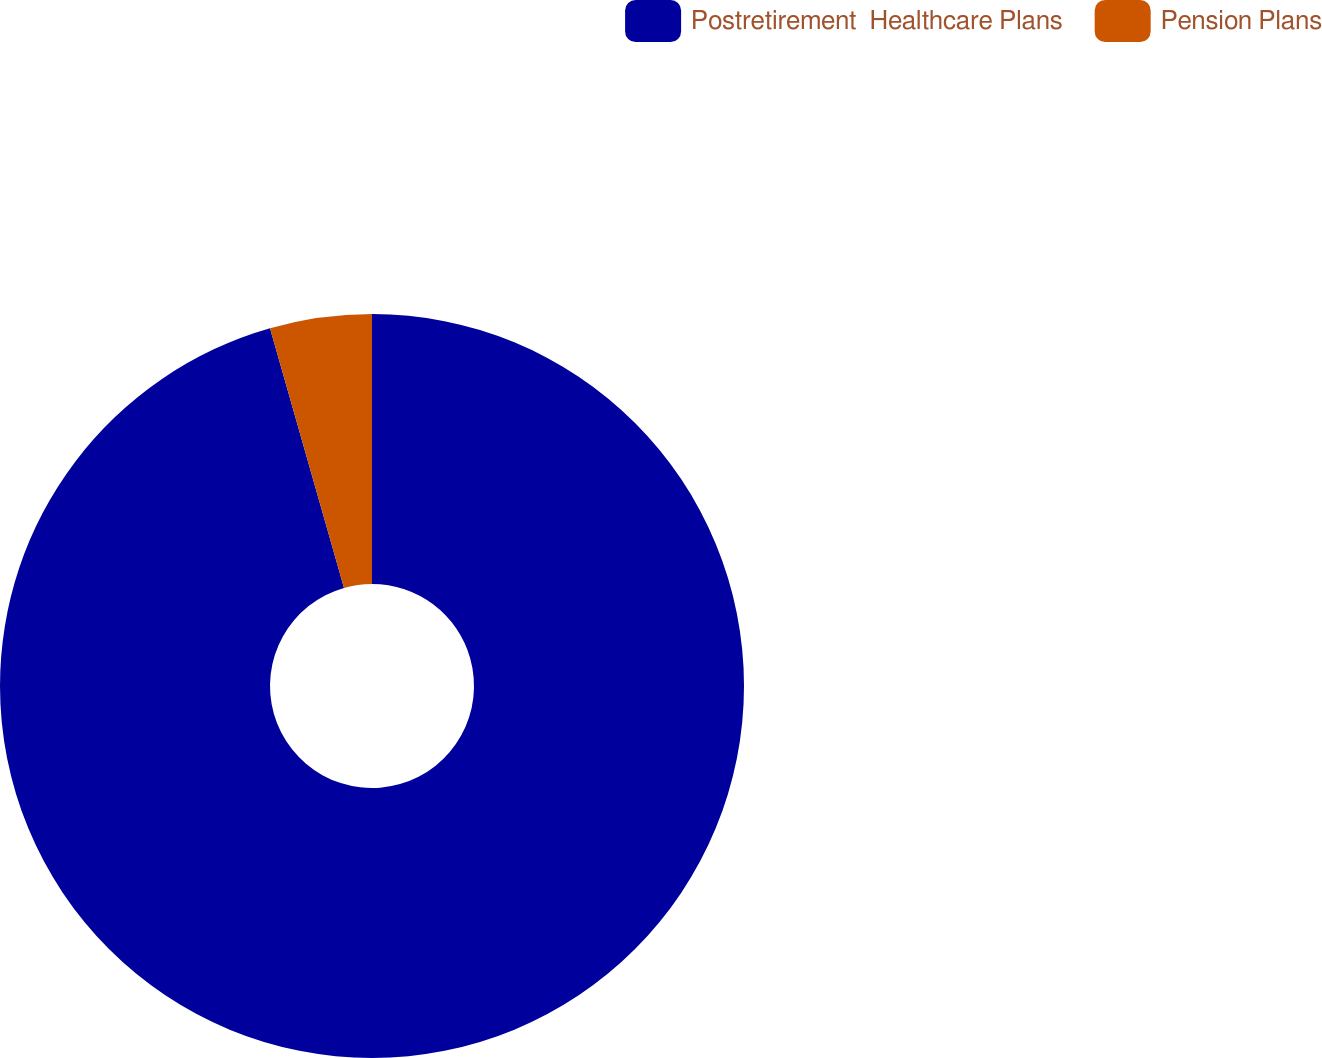Convert chart. <chart><loc_0><loc_0><loc_500><loc_500><pie_chart><fcel>Postretirement  Healthcare Plans<fcel>Pension Plans<nl><fcel>95.58%<fcel>4.42%<nl></chart> 